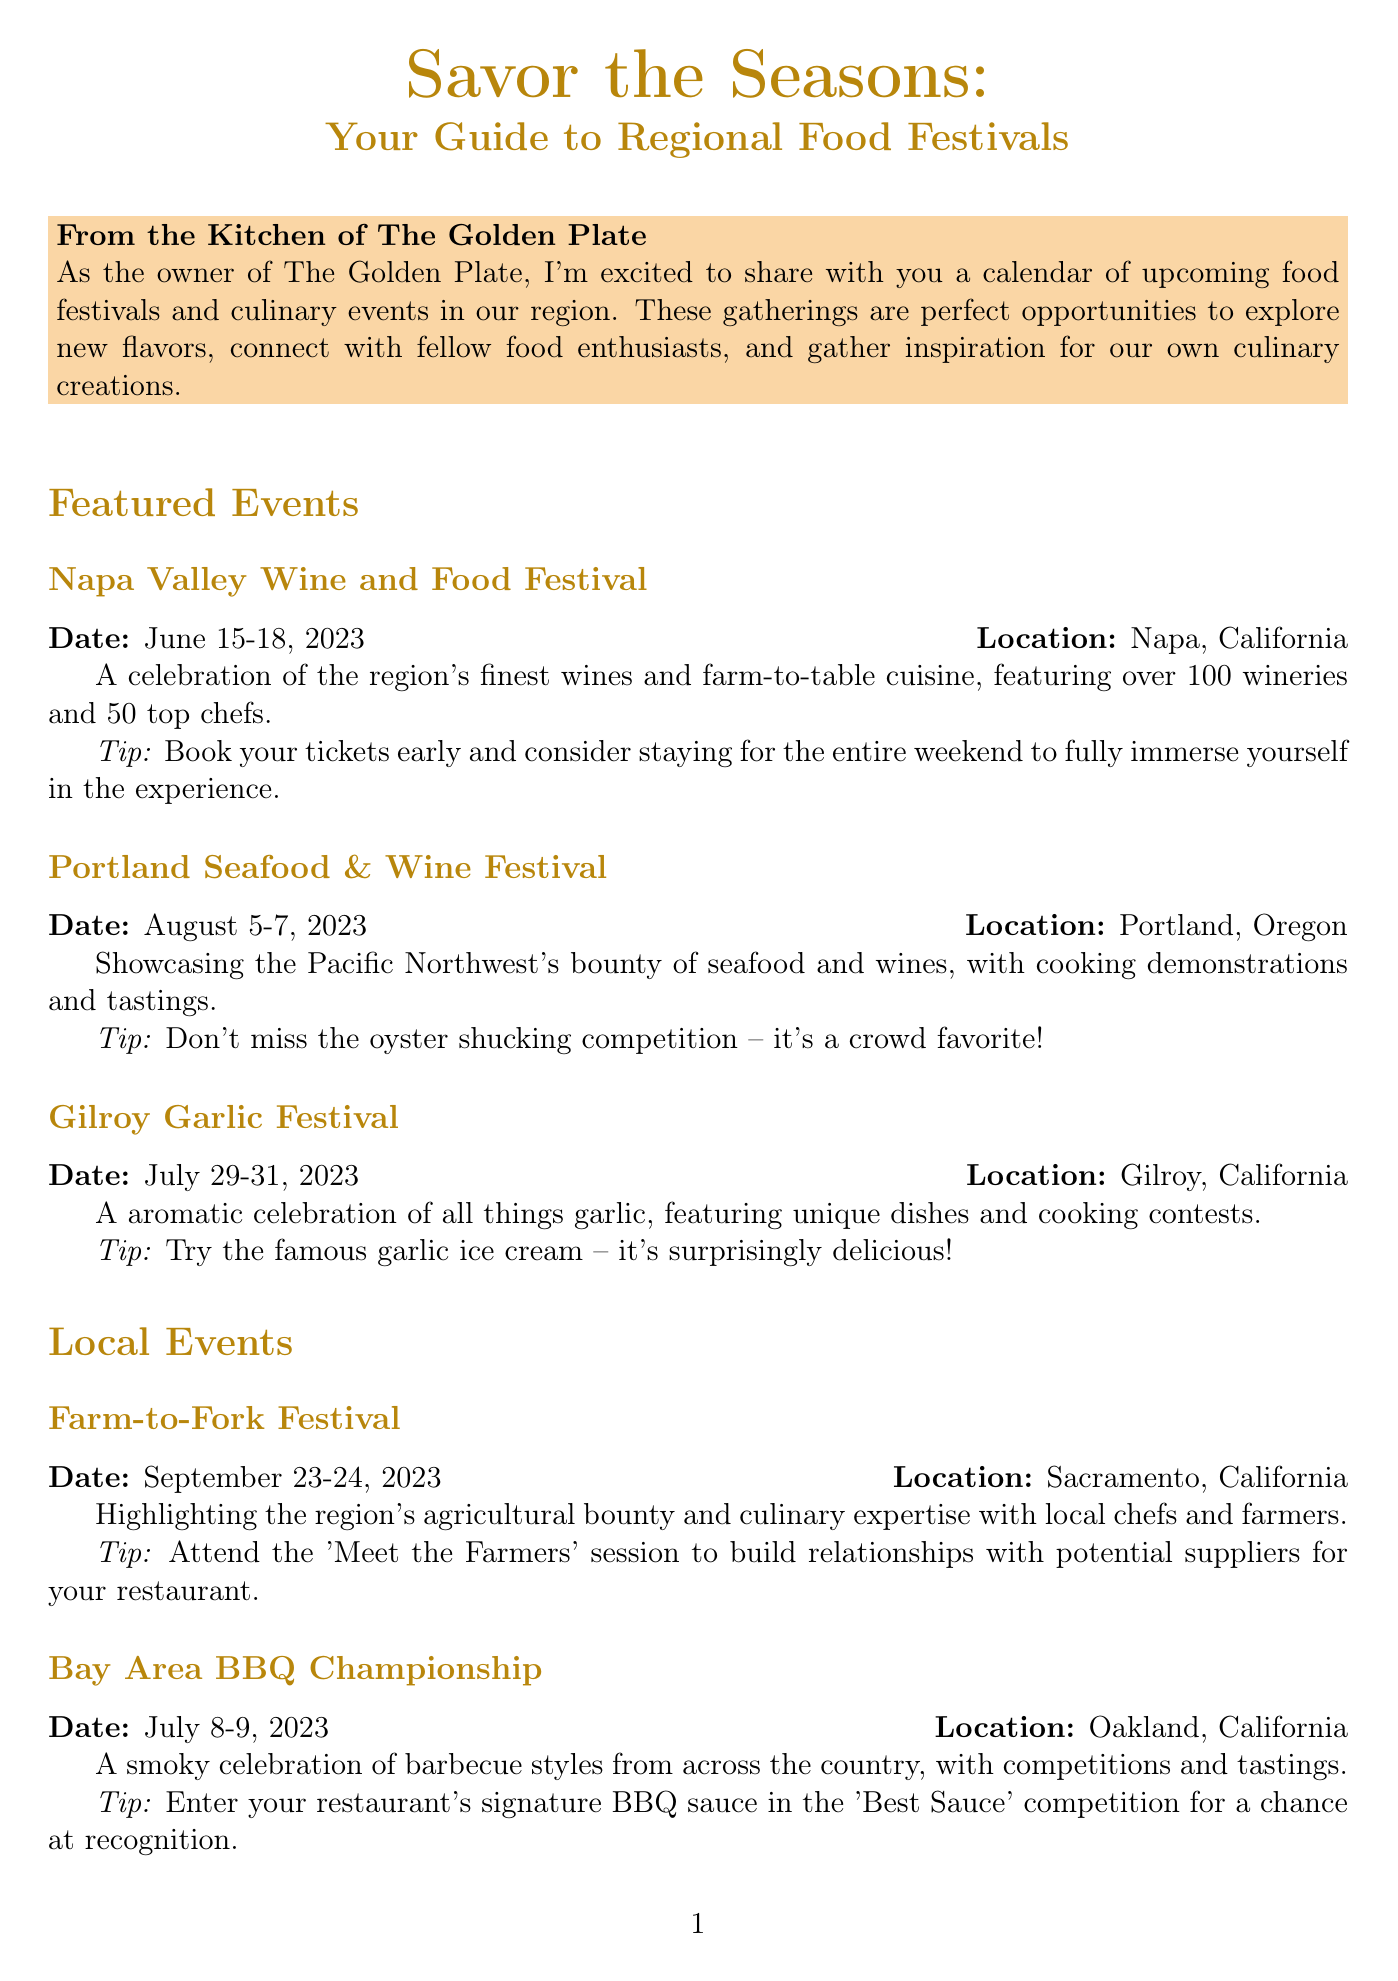what is the name of the first featured event? The first featured event mentioned in the document is the Napa Valley Wine and Food Festival.
Answer: Napa Valley Wine and Food Festival when is the Gilroy Garlic Festival scheduled? The document states that the Gilroy Garlic Festival is scheduled for July 29-31, 2023.
Answer: July 29-31, 2023 what type of cuisine is highlighted at the Portland Seafood & Wine Festival? The festival showcases the Pacific Northwest's seafood and wines along with cooking demonstrations.
Answer: Seafood and wines how many wineries are participating in the Napa Valley Wine and Food Festival? The document indicates that over 100 wineries are participating in this festival.
Answer: Over 100 what is one tip for participating in the Farm-to-Fork Festival? The document advises attendees to attend the 'Meet the Farmers' session to build relationships with potential suppliers.
Answer: Attend the 'Meet the Farmers' session which city's culinary event focuses on barbecue styles? The Bay Area BBQ Championship in Oakland, California focuses on barbecue styles.
Answer: Oakland what is a key activity suggested at the Western Foodservice & Hospitality Expo? The document suggests focusing on the 'New Product Showcase' to discover innovative products.
Answer: New Product Showcase what type of event is the Bay Area BBQ Championship categorized as? The event is categorized as a celebration of barbecue styles with competitions and tastings.
Answer: Celebration of barbecue styles 